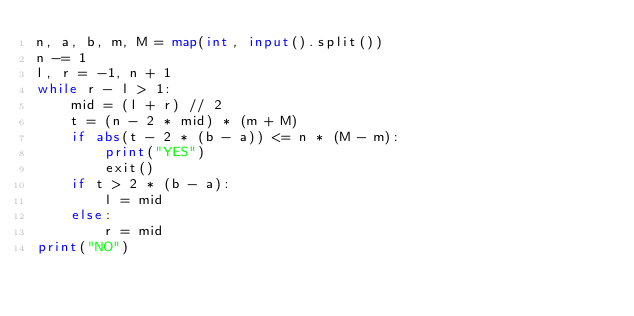<code> <loc_0><loc_0><loc_500><loc_500><_Python_>n, a, b, m, M = map(int, input().split())
n -= 1
l, r = -1, n + 1
while r - l > 1:
	mid = (l + r) // 2
	t = (n - 2 * mid) * (m + M)
	if abs(t - 2 * (b - a)) <= n * (M - m):
		print("YES")
		exit()
	if t > 2 * (b - a):
		l = mid
	else:
		r = mid
print("NO")</code> 